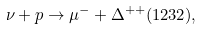<formula> <loc_0><loc_0><loc_500><loc_500>\nu + p \rightarrow \mu ^ { - } + \Delta ^ { + + } ( 1 2 3 2 ) ,</formula> 